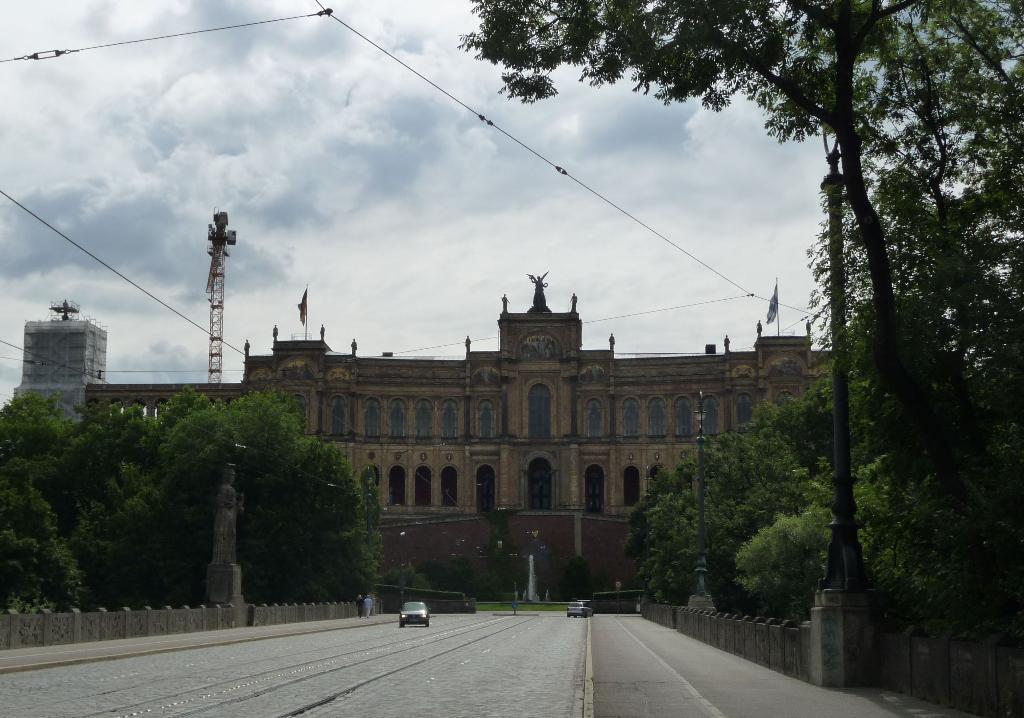In one or two sentences, can you explain what this image depicts? In the background of the image there are buildings. At the bottom of the image there is road. There are cars. To the both sides of the image there are trees. At the top of the image there is sky. 